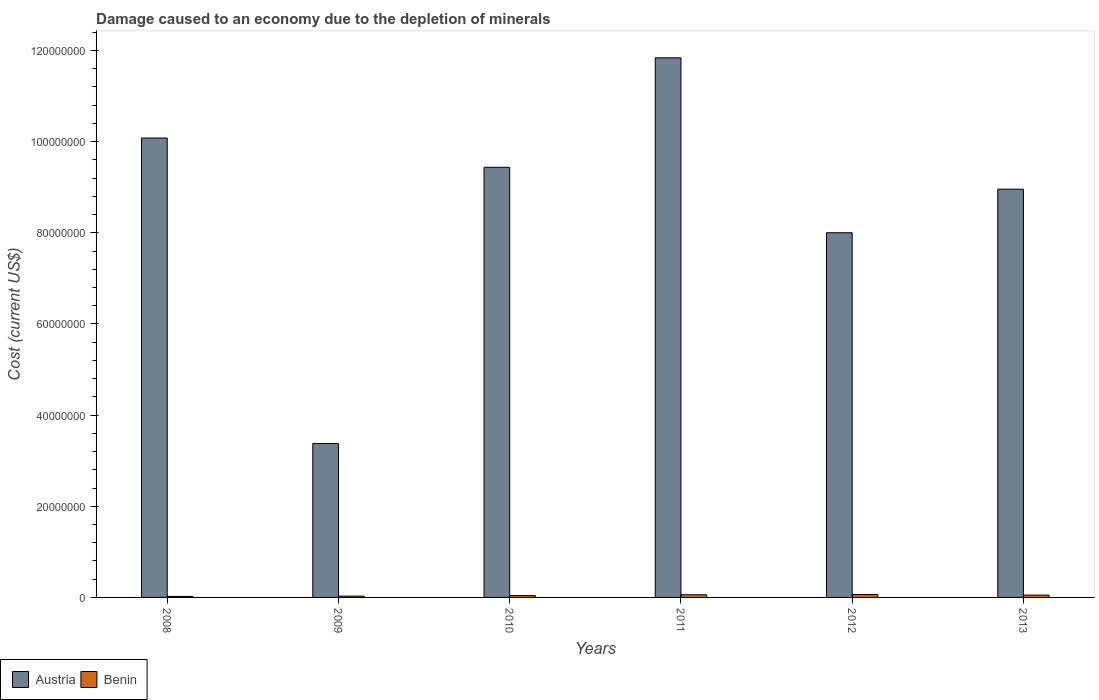How many different coloured bars are there?
Your answer should be very brief. 2. Are the number of bars on each tick of the X-axis equal?
Ensure brevity in your answer.  Yes. How many bars are there on the 6th tick from the left?
Ensure brevity in your answer.  2. How many bars are there on the 1st tick from the right?
Your response must be concise. 2. What is the label of the 6th group of bars from the left?
Offer a very short reply. 2013. What is the cost of damage caused due to the depletion of minerals in Benin in 2009?
Your response must be concise. 2.85e+05. Across all years, what is the maximum cost of damage caused due to the depletion of minerals in Benin?
Keep it short and to the point. 6.32e+05. Across all years, what is the minimum cost of damage caused due to the depletion of minerals in Benin?
Your response must be concise. 2.23e+05. What is the total cost of damage caused due to the depletion of minerals in Austria in the graph?
Offer a very short reply. 5.17e+08. What is the difference between the cost of damage caused due to the depletion of minerals in Austria in 2008 and that in 2011?
Ensure brevity in your answer.  -1.76e+07. What is the difference between the cost of damage caused due to the depletion of minerals in Austria in 2009 and the cost of damage caused due to the depletion of minerals in Benin in 2013?
Your response must be concise. 3.33e+07. What is the average cost of damage caused due to the depletion of minerals in Austria per year?
Provide a succinct answer. 8.62e+07. In the year 2009, what is the difference between the cost of damage caused due to the depletion of minerals in Austria and cost of damage caused due to the depletion of minerals in Benin?
Offer a terse response. 3.35e+07. In how many years, is the cost of damage caused due to the depletion of minerals in Benin greater than 64000000 US$?
Offer a very short reply. 0. What is the ratio of the cost of damage caused due to the depletion of minerals in Austria in 2012 to that in 2013?
Make the answer very short. 0.89. Is the difference between the cost of damage caused due to the depletion of minerals in Austria in 2011 and 2013 greater than the difference between the cost of damage caused due to the depletion of minerals in Benin in 2011 and 2013?
Give a very brief answer. Yes. What is the difference between the highest and the second highest cost of damage caused due to the depletion of minerals in Austria?
Your answer should be compact. 1.76e+07. What is the difference between the highest and the lowest cost of damage caused due to the depletion of minerals in Austria?
Offer a very short reply. 8.46e+07. Is the sum of the cost of damage caused due to the depletion of minerals in Austria in 2009 and 2010 greater than the maximum cost of damage caused due to the depletion of minerals in Benin across all years?
Make the answer very short. Yes. What does the 1st bar from the left in 2013 represents?
Provide a short and direct response. Austria. What does the 2nd bar from the right in 2008 represents?
Give a very brief answer. Austria. How many years are there in the graph?
Offer a very short reply. 6. Are the values on the major ticks of Y-axis written in scientific E-notation?
Make the answer very short. No. Does the graph contain grids?
Keep it short and to the point. No. Where does the legend appear in the graph?
Your answer should be compact. Bottom left. How are the legend labels stacked?
Your answer should be very brief. Horizontal. What is the title of the graph?
Ensure brevity in your answer.  Damage caused to an economy due to the depletion of minerals. Does "Kiribati" appear as one of the legend labels in the graph?
Give a very brief answer. No. What is the label or title of the X-axis?
Provide a short and direct response. Years. What is the label or title of the Y-axis?
Provide a short and direct response. Cost (current US$). What is the Cost (current US$) in Austria in 2008?
Ensure brevity in your answer.  1.01e+08. What is the Cost (current US$) of Benin in 2008?
Give a very brief answer. 2.23e+05. What is the Cost (current US$) in Austria in 2009?
Give a very brief answer. 3.38e+07. What is the Cost (current US$) in Benin in 2009?
Offer a terse response. 2.85e+05. What is the Cost (current US$) in Austria in 2010?
Offer a terse response. 9.44e+07. What is the Cost (current US$) of Benin in 2010?
Your answer should be compact. 4.13e+05. What is the Cost (current US$) in Austria in 2011?
Your answer should be very brief. 1.18e+08. What is the Cost (current US$) of Benin in 2011?
Offer a terse response. 5.80e+05. What is the Cost (current US$) of Austria in 2012?
Make the answer very short. 8.00e+07. What is the Cost (current US$) in Benin in 2012?
Offer a very short reply. 6.32e+05. What is the Cost (current US$) in Austria in 2013?
Offer a very short reply. 8.96e+07. What is the Cost (current US$) of Benin in 2013?
Make the answer very short. 5.09e+05. Across all years, what is the maximum Cost (current US$) of Austria?
Offer a terse response. 1.18e+08. Across all years, what is the maximum Cost (current US$) of Benin?
Your answer should be compact. 6.32e+05. Across all years, what is the minimum Cost (current US$) in Austria?
Provide a succinct answer. 3.38e+07. Across all years, what is the minimum Cost (current US$) of Benin?
Offer a terse response. 2.23e+05. What is the total Cost (current US$) of Austria in the graph?
Your answer should be very brief. 5.17e+08. What is the total Cost (current US$) in Benin in the graph?
Your answer should be compact. 2.64e+06. What is the difference between the Cost (current US$) of Austria in 2008 and that in 2009?
Your response must be concise. 6.70e+07. What is the difference between the Cost (current US$) of Benin in 2008 and that in 2009?
Your answer should be compact. -6.27e+04. What is the difference between the Cost (current US$) of Austria in 2008 and that in 2010?
Offer a terse response. 6.42e+06. What is the difference between the Cost (current US$) in Benin in 2008 and that in 2010?
Provide a short and direct response. -1.90e+05. What is the difference between the Cost (current US$) of Austria in 2008 and that in 2011?
Make the answer very short. -1.76e+07. What is the difference between the Cost (current US$) in Benin in 2008 and that in 2011?
Provide a succinct answer. -3.58e+05. What is the difference between the Cost (current US$) of Austria in 2008 and that in 2012?
Provide a succinct answer. 2.08e+07. What is the difference between the Cost (current US$) of Benin in 2008 and that in 2012?
Provide a short and direct response. -4.09e+05. What is the difference between the Cost (current US$) in Austria in 2008 and that in 2013?
Ensure brevity in your answer.  1.12e+07. What is the difference between the Cost (current US$) of Benin in 2008 and that in 2013?
Provide a succinct answer. -2.86e+05. What is the difference between the Cost (current US$) in Austria in 2009 and that in 2010?
Ensure brevity in your answer.  -6.06e+07. What is the difference between the Cost (current US$) of Benin in 2009 and that in 2010?
Offer a very short reply. -1.28e+05. What is the difference between the Cost (current US$) of Austria in 2009 and that in 2011?
Provide a succinct answer. -8.46e+07. What is the difference between the Cost (current US$) of Benin in 2009 and that in 2011?
Offer a very short reply. -2.95e+05. What is the difference between the Cost (current US$) in Austria in 2009 and that in 2012?
Your answer should be very brief. -4.62e+07. What is the difference between the Cost (current US$) of Benin in 2009 and that in 2012?
Give a very brief answer. -3.46e+05. What is the difference between the Cost (current US$) in Austria in 2009 and that in 2013?
Your answer should be compact. -5.58e+07. What is the difference between the Cost (current US$) of Benin in 2009 and that in 2013?
Your answer should be very brief. -2.23e+05. What is the difference between the Cost (current US$) in Austria in 2010 and that in 2011?
Offer a very short reply. -2.40e+07. What is the difference between the Cost (current US$) of Benin in 2010 and that in 2011?
Provide a succinct answer. -1.67e+05. What is the difference between the Cost (current US$) in Austria in 2010 and that in 2012?
Make the answer very short. 1.44e+07. What is the difference between the Cost (current US$) in Benin in 2010 and that in 2012?
Provide a short and direct response. -2.19e+05. What is the difference between the Cost (current US$) in Austria in 2010 and that in 2013?
Give a very brief answer. 4.80e+06. What is the difference between the Cost (current US$) in Benin in 2010 and that in 2013?
Keep it short and to the point. -9.54e+04. What is the difference between the Cost (current US$) of Austria in 2011 and that in 2012?
Your response must be concise. 3.84e+07. What is the difference between the Cost (current US$) in Benin in 2011 and that in 2012?
Your answer should be compact. -5.11e+04. What is the difference between the Cost (current US$) of Austria in 2011 and that in 2013?
Offer a terse response. 2.88e+07. What is the difference between the Cost (current US$) of Benin in 2011 and that in 2013?
Keep it short and to the point. 7.20e+04. What is the difference between the Cost (current US$) of Austria in 2012 and that in 2013?
Your answer should be compact. -9.55e+06. What is the difference between the Cost (current US$) of Benin in 2012 and that in 2013?
Offer a terse response. 1.23e+05. What is the difference between the Cost (current US$) in Austria in 2008 and the Cost (current US$) in Benin in 2009?
Ensure brevity in your answer.  1.01e+08. What is the difference between the Cost (current US$) in Austria in 2008 and the Cost (current US$) in Benin in 2010?
Offer a very short reply. 1.00e+08. What is the difference between the Cost (current US$) of Austria in 2008 and the Cost (current US$) of Benin in 2011?
Offer a very short reply. 1.00e+08. What is the difference between the Cost (current US$) in Austria in 2008 and the Cost (current US$) in Benin in 2012?
Give a very brief answer. 1.00e+08. What is the difference between the Cost (current US$) in Austria in 2008 and the Cost (current US$) in Benin in 2013?
Your answer should be compact. 1.00e+08. What is the difference between the Cost (current US$) in Austria in 2009 and the Cost (current US$) in Benin in 2010?
Offer a terse response. 3.34e+07. What is the difference between the Cost (current US$) in Austria in 2009 and the Cost (current US$) in Benin in 2011?
Your answer should be compact. 3.32e+07. What is the difference between the Cost (current US$) in Austria in 2009 and the Cost (current US$) in Benin in 2012?
Give a very brief answer. 3.31e+07. What is the difference between the Cost (current US$) of Austria in 2009 and the Cost (current US$) of Benin in 2013?
Ensure brevity in your answer.  3.33e+07. What is the difference between the Cost (current US$) of Austria in 2010 and the Cost (current US$) of Benin in 2011?
Keep it short and to the point. 9.38e+07. What is the difference between the Cost (current US$) in Austria in 2010 and the Cost (current US$) in Benin in 2012?
Offer a terse response. 9.37e+07. What is the difference between the Cost (current US$) of Austria in 2010 and the Cost (current US$) of Benin in 2013?
Provide a succinct answer. 9.39e+07. What is the difference between the Cost (current US$) in Austria in 2011 and the Cost (current US$) in Benin in 2012?
Offer a terse response. 1.18e+08. What is the difference between the Cost (current US$) of Austria in 2011 and the Cost (current US$) of Benin in 2013?
Keep it short and to the point. 1.18e+08. What is the difference between the Cost (current US$) in Austria in 2012 and the Cost (current US$) in Benin in 2013?
Provide a short and direct response. 7.95e+07. What is the average Cost (current US$) of Austria per year?
Make the answer very short. 8.62e+07. What is the average Cost (current US$) of Benin per year?
Keep it short and to the point. 4.40e+05. In the year 2008, what is the difference between the Cost (current US$) in Austria and Cost (current US$) in Benin?
Ensure brevity in your answer.  1.01e+08. In the year 2009, what is the difference between the Cost (current US$) of Austria and Cost (current US$) of Benin?
Give a very brief answer. 3.35e+07. In the year 2010, what is the difference between the Cost (current US$) of Austria and Cost (current US$) of Benin?
Your response must be concise. 9.40e+07. In the year 2011, what is the difference between the Cost (current US$) of Austria and Cost (current US$) of Benin?
Make the answer very short. 1.18e+08. In the year 2012, what is the difference between the Cost (current US$) of Austria and Cost (current US$) of Benin?
Ensure brevity in your answer.  7.94e+07. In the year 2013, what is the difference between the Cost (current US$) of Austria and Cost (current US$) of Benin?
Offer a very short reply. 8.91e+07. What is the ratio of the Cost (current US$) of Austria in 2008 to that in 2009?
Provide a succinct answer. 2.98. What is the ratio of the Cost (current US$) of Benin in 2008 to that in 2009?
Provide a short and direct response. 0.78. What is the ratio of the Cost (current US$) of Austria in 2008 to that in 2010?
Give a very brief answer. 1.07. What is the ratio of the Cost (current US$) in Benin in 2008 to that in 2010?
Provide a short and direct response. 0.54. What is the ratio of the Cost (current US$) in Austria in 2008 to that in 2011?
Give a very brief answer. 0.85. What is the ratio of the Cost (current US$) in Benin in 2008 to that in 2011?
Your response must be concise. 0.38. What is the ratio of the Cost (current US$) in Austria in 2008 to that in 2012?
Your answer should be compact. 1.26. What is the ratio of the Cost (current US$) in Benin in 2008 to that in 2012?
Your answer should be very brief. 0.35. What is the ratio of the Cost (current US$) of Austria in 2008 to that in 2013?
Offer a very short reply. 1.13. What is the ratio of the Cost (current US$) in Benin in 2008 to that in 2013?
Your response must be concise. 0.44. What is the ratio of the Cost (current US$) of Austria in 2009 to that in 2010?
Your response must be concise. 0.36. What is the ratio of the Cost (current US$) in Benin in 2009 to that in 2010?
Your answer should be very brief. 0.69. What is the ratio of the Cost (current US$) in Austria in 2009 to that in 2011?
Your response must be concise. 0.29. What is the ratio of the Cost (current US$) of Benin in 2009 to that in 2011?
Give a very brief answer. 0.49. What is the ratio of the Cost (current US$) of Austria in 2009 to that in 2012?
Give a very brief answer. 0.42. What is the ratio of the Cost (current US$) of Benin in 2009 to that in 2012?
Make the answer very short. 0.45. What is the ratio of the Cost (current US$) in Austria in 2009 to that in 2013?
Offer a terse response. 0.38. What is the ratio of the Cost (current US$) of Benin in 2009 to that in 2013?
Your answer should be very brief. 0.56. What is the ratio of the Cost (current US$) of Austria in 2010 to that in 2011?
Offer a terse response. 0.8. What is the ratio of the Cost (current US$) in Benin in 2010 to that in 2011?
Provide a short and direct response. 0.71. What is the ratio of the Cost (current US$) in Austria in 2010 to that in 2012?
Provide a succinct answer. 1.18. What is the ratio of the Cost (current US$) in Benin in 2010 to that in 2012?
Offer a terse response. 0.65. What is the ratio of the Cost (current US$) in Austria in 2010 to that in 2013?
Make the answer very short. 1.05. What is the ratio of the Cost (current US$) in Benin in 2010 to that in 2013?
Your answer should be very brief. 0.81. What is the ratio of the Cost (current US$) in Austria in 2011 to that in 2012?
Make the answer very short. 1.48. What is the ratio of the Cost (current US$) of Benin in 2011 to that in 2012?
Provide a short and direct response. 0.92. What is the ratio of the Cost (current US$) in Austria in 2011 to that in 2013?
Provide a short and direct response. 1.32. What is the ratio of the Cost (current US$) in Benin in 2011 to that in 2013?
Your answer should be compact. 1.14. What is the ratio of the Cost (current US$) in Austria in 2012 to that in 2013?
Your answer should be very brief. 0.89. What is the ratio of the Cost (current US$) of Benin in 2012 to that in 2013?
Your answer should be very brief. 1.24. What is the difference between the highest and the second highest Cost (current US$) in Austria?
Provide a succinct answer. 1.76e+07. What is the difference between the highest and the second highest Cost (current US$) in Benin?
Offer a terse response. 5.11e+04. What is the difference between the highest and the lowest Cost (current US$) of Austria?
Your response must be concise. 8.46e+07. What is the difference between the highest and the lowest Cost (current US$) in Benin?
Make the answer very short. 4.09e+05. 